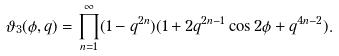<formula> <loc_0><loc_0><loc_500><loc_500>\vartheta _ { 3 } ( \phi , q ) = \prod _ { n = 1 } ^ { \infty } ( 1 - q ^ { 2 n } ) ( 1 + 2 q ^ { 2 n - 1 } \cos 2 \phi + q ^ { 4 n - 2 } ) .</formula> 